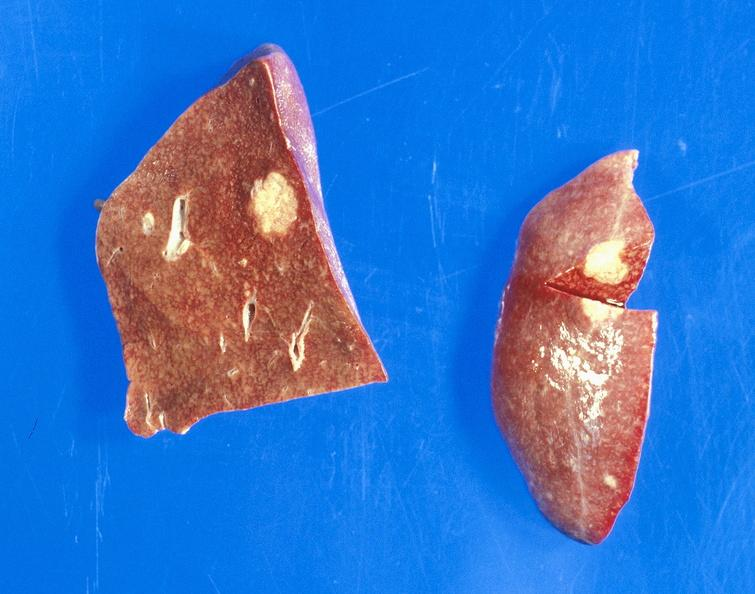what is present?
Answer the question using a single word or phrase. Liver 